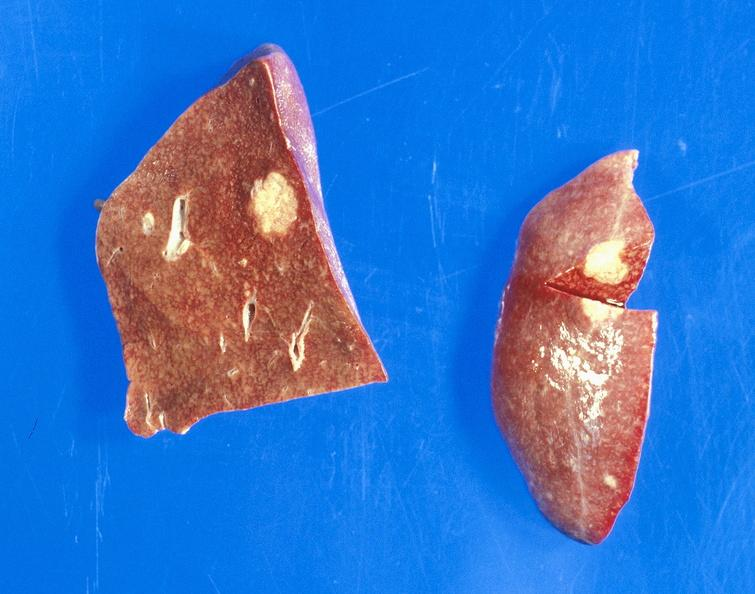what is present?
Answer the question using a single word or phrase. Liver 